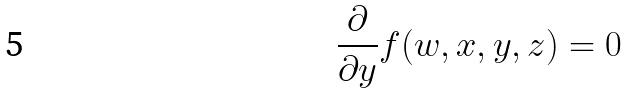<formula> <loc_0><loc_0><loc_500><loc_500>\frac { \partial } { \partial y } f ( w , x , y , z ) = 0</formula> 